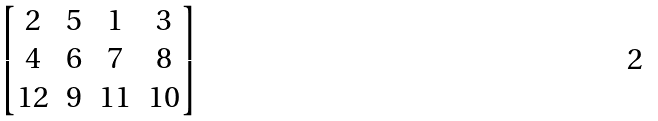<formula> <loc_0><loc_0><loc_500><loc_500>\begin{bmatrix} 2 & 5 & 1 & 3 \\ 4 & 6 & 7 & 8 \\ 1 2 & 9 & 1 1 & 1 0 \end{bmatrix}</formula> 